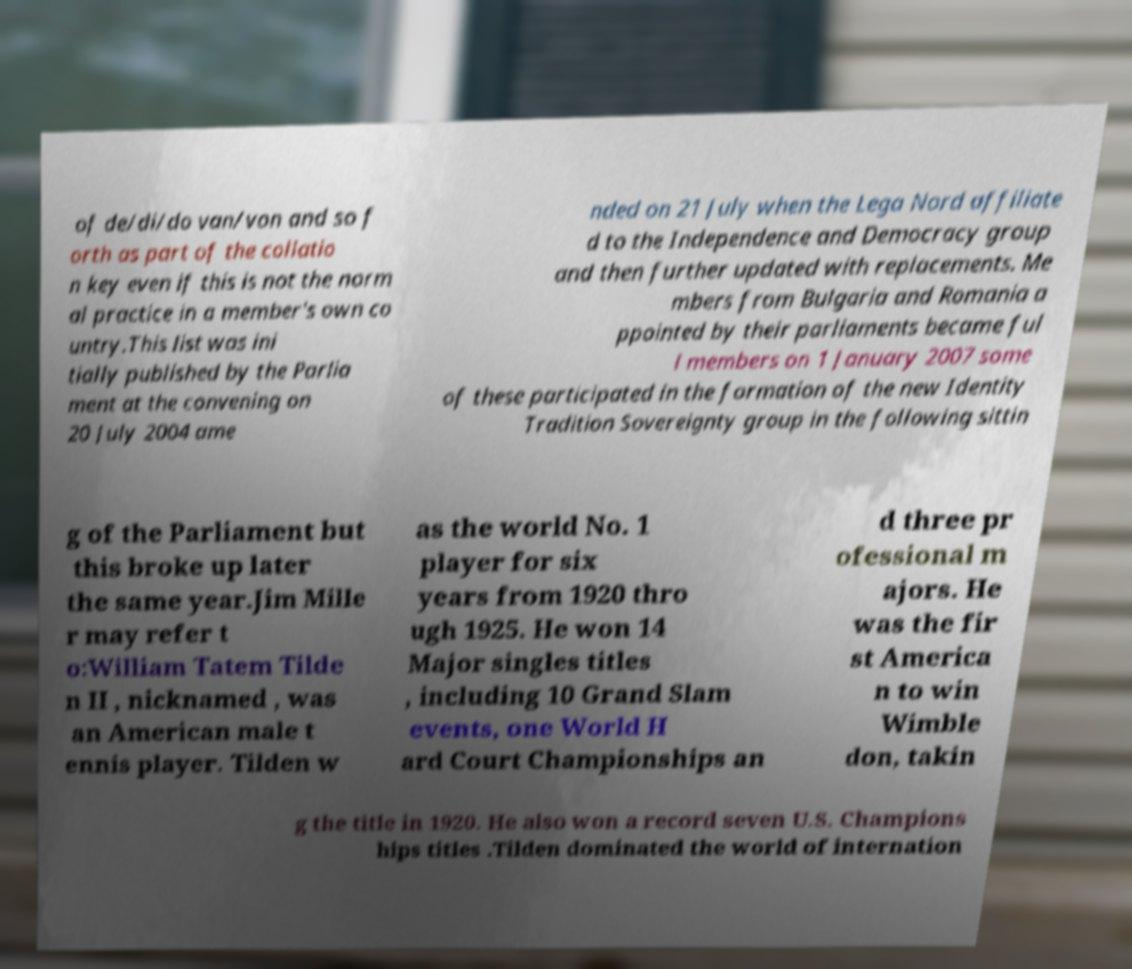Could you extract and type out the text from this image? of de/di/do van/von and so f orth as part of the collatio n key even if this is not the norm al practice in a member's own co untry.This list was ini tially published by the Parlia ment at the convening on 20 July 2004 ame nded on 21 July when the Lega Nord affiliate d to the Independence and Democracy group and then further updated with replacements. Me mbers from Bulgaria and Romania a ppointed by their parliaments became ful l members on 1 January 2007 some of these participated in the formation of the new Identity Tradition Sovereignty group in the following sittin g of the Parliament but this broke up later the same year.Jim Mille r may refer t o:William Tatem Tilde n II , nicknamed , was an American male t ennis player. Tilden w as the world No. 1 player for six years from 1920 thro ugh 1925. He won 14 Major singles titles , including 10 Grand Slam events, one World H ard Court Championships an d three pr ofessional m ajors. He was the fir st America n to win Wimble don, takin g the title in 1920. He also won a record seven U.S. Champions hips titles .Tilden dominated the world of internation 